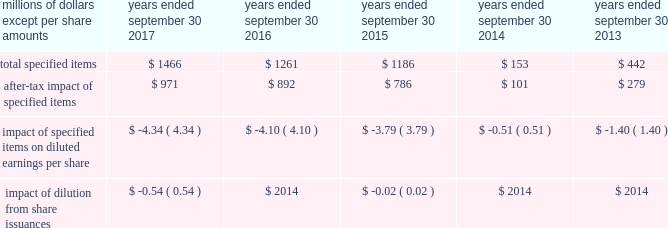( a ) excludes discontinued operations .
( b ) earnings before interest expense and taxes as a percent of average total assets .
( c ) total debt as a percent of the sum of total debt , shareholders 2019 equity and non-current deferred income tax liabilities .
The results above include the impact of the specified items detailed below .
Additional discussion regarding the specified items in fiscal years 2017 , 2016 and 2015 are provided in item 7 .
Management 2019s discussion and analysis of financial condition and results of operations. .
Item 7 .
Management 2019s discussion and analysis of financial condition and results of operations the following commentary should be read in conjunction with the consolidated financial statements and accompanying notes .
Within the tables presented throughout this discussion , certain columns may not add due to the use of rounded numbers for disclosure purposes .
Percentages and earnings per share amounts presented are calculated from the underlying amounts .
References to years throughout this discussion relate to our fiscal years , which end on september 30 .
Company overview description of the company and business segments becton , dickinson and company ( 201cbd 201d ) is a global medical technology company engaged in the development , manufacture and sale of a broad range of medical supplies , devices , laboratory equipment and diagnostic products used by healthcare institutions , life science researchers , clinical laboratories , the pharmaceutical industry and the general public .
The company's organizational structure is based upon two principal business segments , bd medical ( 201cmedical 201d ) and bd life sciences ( 201clife sciences 201d ) .
Bd 2019s products are manufactured and sold worldwide .
Our products are marketed in the united states and internationally through independent distribution channels and directly to end-users by bd and independent sales representatives .
We organize our operations outside the united states as follows : europe ; ema ( which includes the commonwealth of independent states , the middle east and africa ) ; greater asia ( which includes japan and asia pacific ) ; latin america ( which includes mexico , central america , the caribbean , and south america ) ; and canada .
We continue to pursue growth opportunities in emerging markets , which include the following geographic regions : eastern europe , the middle east , africa , latin america and certain countries within asia pacific .
We are primarily focused on certain countries whose healthcare systems are expanding , in particular , china and india .
Strategic objectives bd remains focused on delivering sustainable growth and shareholder value , while making appropriate investments for the future .
Bd management operates the business consistent with the following core strategies : 2022 to increase revenue growth by focusing on our core products , services and solutions that deliver greater benefits to patients , healthcare workers and researchers; .
What is the percentage increase for total specified items from 2014-2015? 
Computations: ((1186 - 153) / 153)
Answer: 6.75163. 